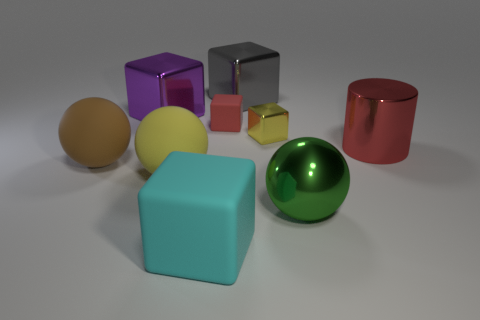There is a cyan rubber thing; is it the same shape as the yellow thing that is left of the big gray metallic cube?
Make the answer very short. No. How many metallic things are either big red objects or cyan blocks?
Give a very brief answer. 1. Are there any large metallic cylinders of the same color as the tiny rubber object?
Your answer should be very brief. Yes. Are any purple metallic cubes visible?
Provide a short and direct response. Yes. Does the big gray thing have the same shape as the large yellow rubber object?
Provide a short and direct response. No. What number of large things are either red metallic objects or red rubber blocks?
Your answer should be compact. 1. What is the color of the tiny rubber thing?
Offer a terse response. Red. What shape is the yellow thing that is to the right of the rubber cube behind the green metallic ball?
Your answer should be very brief. Cube. Is there a tiny red cube made of the same material as the big cylinder?
Make the answer very short. No. Do the cube that is to the left of the yellow ball and the green shiny object have the same size?
Offer a very short reply. Yes. 